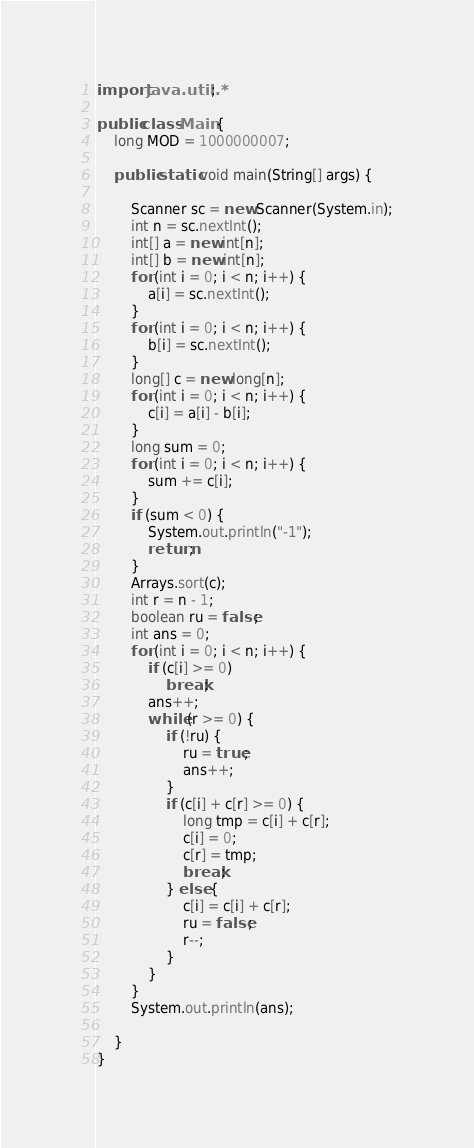Convert code to text. <code><loc_0><loc_0><loc_500><loc_500><_Java_>import java.util.*;

public class Main {
    long MOD = 1000000007;

    public static void main(String[] args) {

        Scanner sc = new Scanner(System.in);
        int n = sc.nextInt();
        int[] a = new int[n];
        int[] b = new int[n];
        for (int i = 0; i < n; i++) {
            a[i] = sc.nextInt();
        }
        for (int i = 0; i < n; i++) {
            b[i] = sc.nextInt();
        }
        long[] c = new long[n];
        for (int i = 0; i < n; i++) {
            c[i] = a[i] - b[i];
        }
        long sum = 0;
        for (int i = 0; i < n; i++) {
            sum += c[i];
        }
        if (sum < 0) {
            System.out.println("-1");
            return;
        }
        Arrays.sort(c);
        int r = n - 1;
        boolean ru = false;
        int ans = 0;
        for (int i = 0; i < n; i++) {
            if (c[i] >= 0)
                break;
            ans++;
            while (r >= 0) {
                if (!ru) {
                    ru = true;
                    ans++;
                }
                if (c[i] + c[r] >= 0) {
                    long tmp = c[i] + c[r];
                    c[i] = 0;
                    c[r] = tmp;
                    break;
                } else {
                    c[i] = c[i] + c[r];
                    ru = false;
                    r--;
                }
            }
        }
        System.out.println(ans);

    }
}</code> 